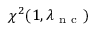Convert formula to latex. <formula><loc_0><loc_0><loc_500><loc_500>\chi ^ { 2 } ( 1 , \lambda _ { n c } )</formula> 